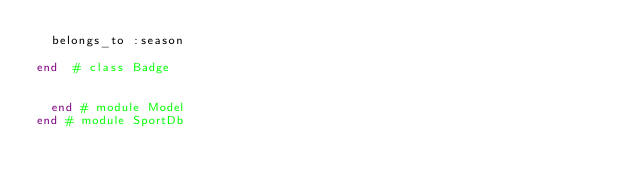Convert code to text. <code><loc_0><loc_0><loc_500><loc_500><_Ruby_>  belongs_to :season

end  # class Badge


  end # module Model
end # module SportDb
</code> 